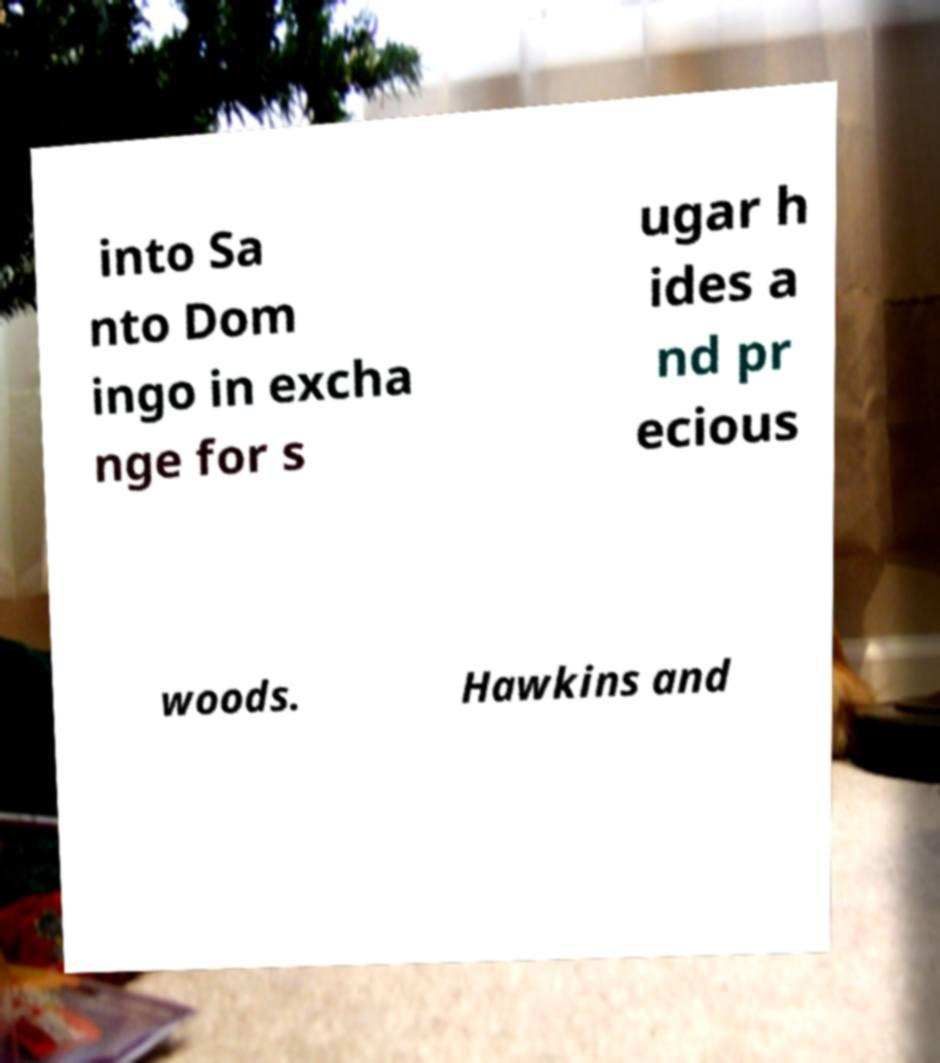I need the written content from this picture converted into text. Can you do that? into Sa nto Dom ingo in excha nge for s ugar h ides a nd pr ecious woods. Hawkins and 